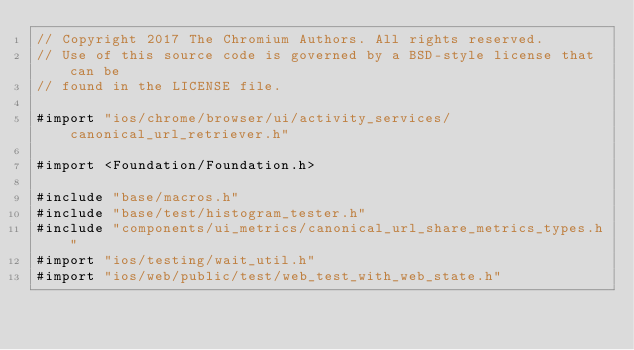Convert code to text. <code><loc_0><loc_0><loc_500><loc_500><_ObjectiveC_>// Copyright 2017 The Chromium Authors. All rights reserved.
// Use of this source code is governed by a BSD-style license that can be
// found in the LICENSE file.

#import "ios/chrome/browser/ui/activity_services/canonical_url_retriever.h"

#import <Foundation/Foundation.h>

#include "base/macros.h"
#include "base/test/histogram_tester.h"
#include "components/ui_metrics/canonical_url_share_metrics_types.h"
#import "ios/testing/wait_util.h"
#import "ios/web/public/test/web_test_with_web_state.h"</code> 